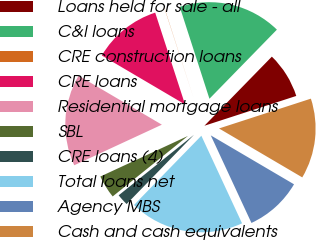Convert chart. <chart><loc_0><loc_0><loc_500><loc_500><pie_chart><fcel>Loans held for sale - all<fcel>C&I loans<fcel>CRE construction loans<fcel>CRE loans<fcel>Residential mortgage loans<fcel>SBL<fcel>CRE loans (4)<fcel>Total loans net<fcel>Agency MBS<fcel>Cash and cash equivalents<nl><fcel>7.7%<fcel>17.28%<fcel>0.03%<fcel>11.53%<fcel>15.37%<fcel>3.87%<fcel>1.95%<fcel>19.2%<fcel>9.62%<fcel>13.45%<nl></chart> 